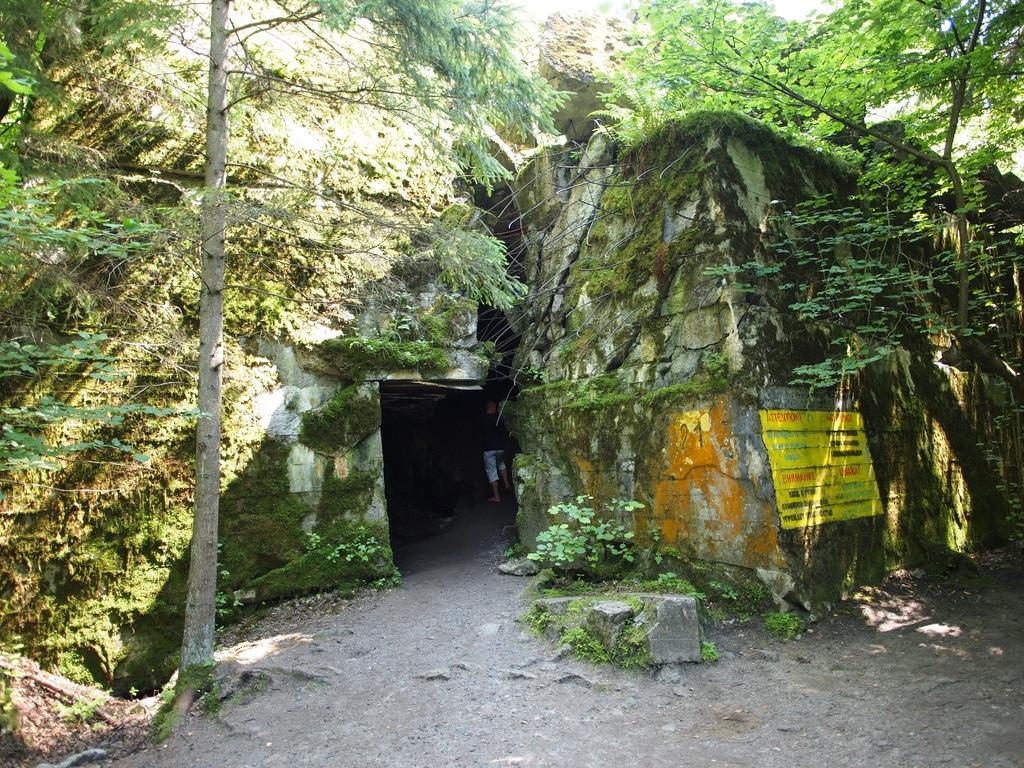Please provide a concise description of this image. In this image we can see cave. On the right and left side of the image we can see trees. 